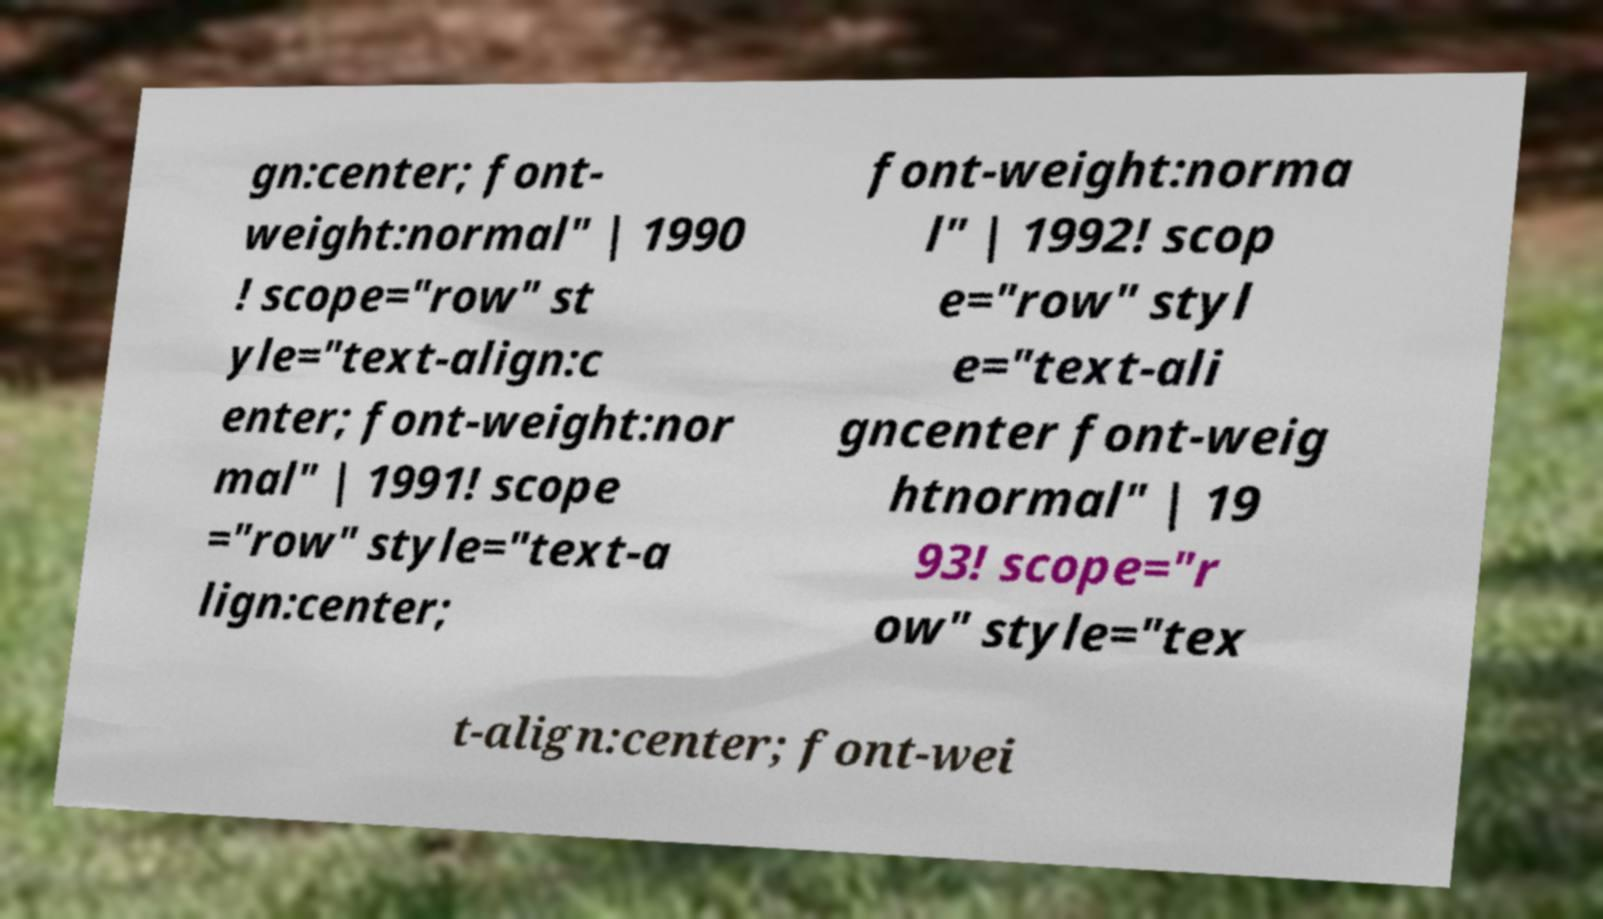There's text embedded in this image that I need extracted. Can you transcribe it verbatim? gn:center; font- weight:normal" | 1990 ! scope="row" st yle="text-align:c enter; font-weight:nor mal" | 1991! scope ="row" style="text-a lign:center; font-weight:norma l" | 1992! scop e="row" styl e="text-ali gncenter font-weig htnormal" | 19 93! scope="r ow" style="tex t-align:center; font-wei 